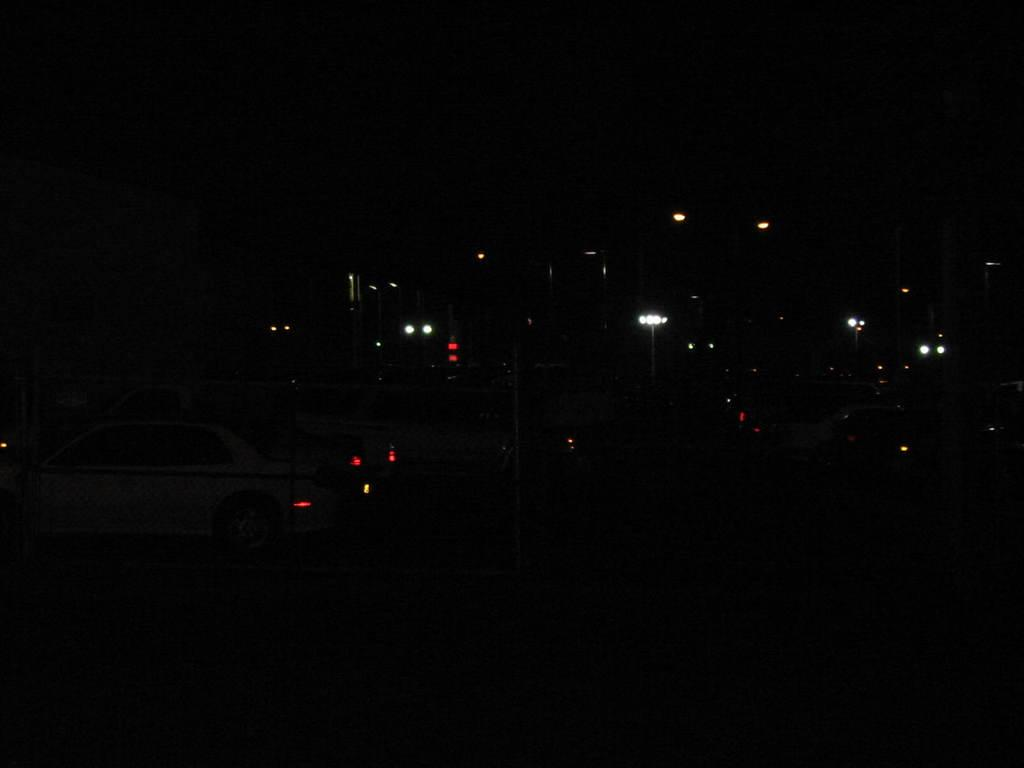What vehicle is located on the left side of the image? There is a car on the left side of the image. What type of structures can be seen in the image? There are lamp poles in the image. How far is the lake from the car in the image? There is no lake present in the image, so it is not possible to determine the distance between the car and a lake. 